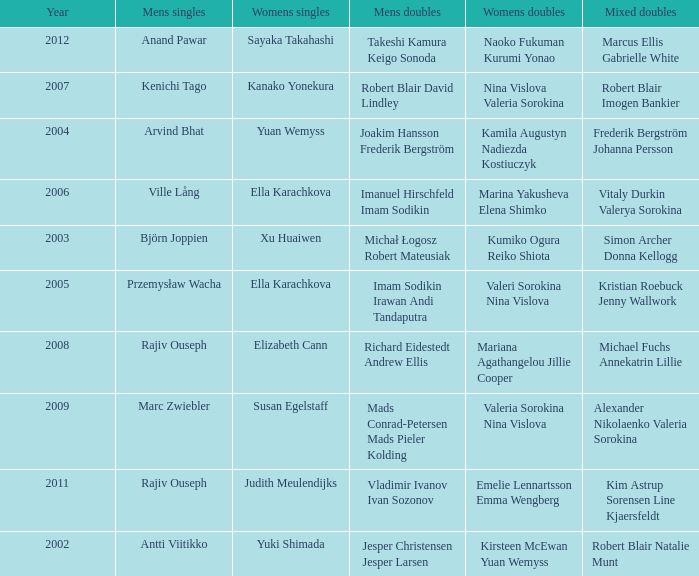Name the men's singles of marina yakusheva elena shimko Ville Lång. 